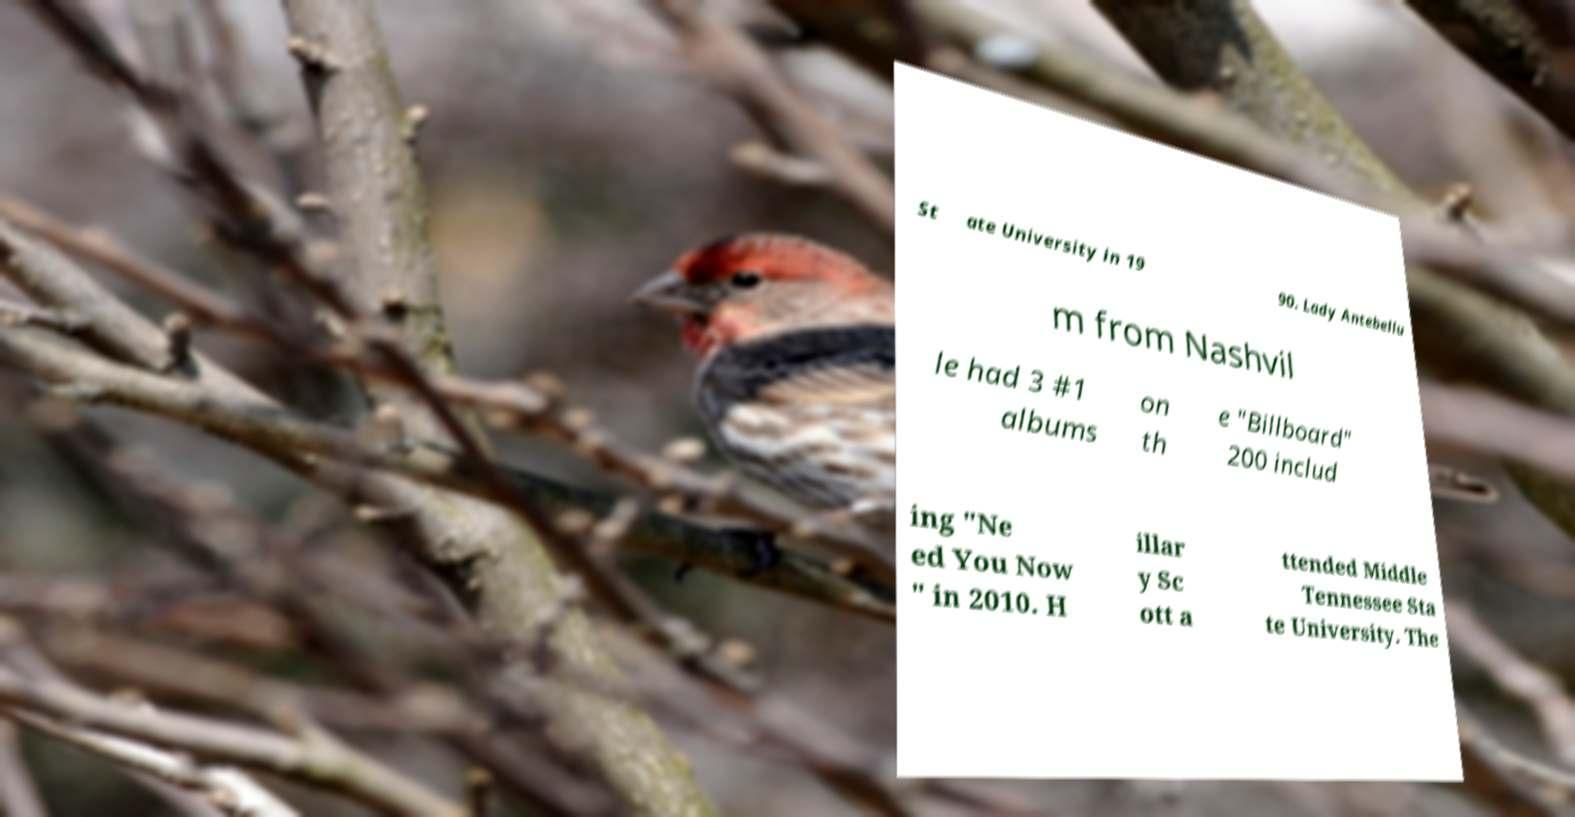For documentation purposes, I need the text within this image transcribed. Could you provide that? St ate University in 19 90. Lady Antebellu m from Nashvil le had 3 #1 albums on th e "Billboard" 200 includ ing "Ne ed You Now " in 2010. H illar y Sc ott a ttended Middle Tennessee Sta te University. The 